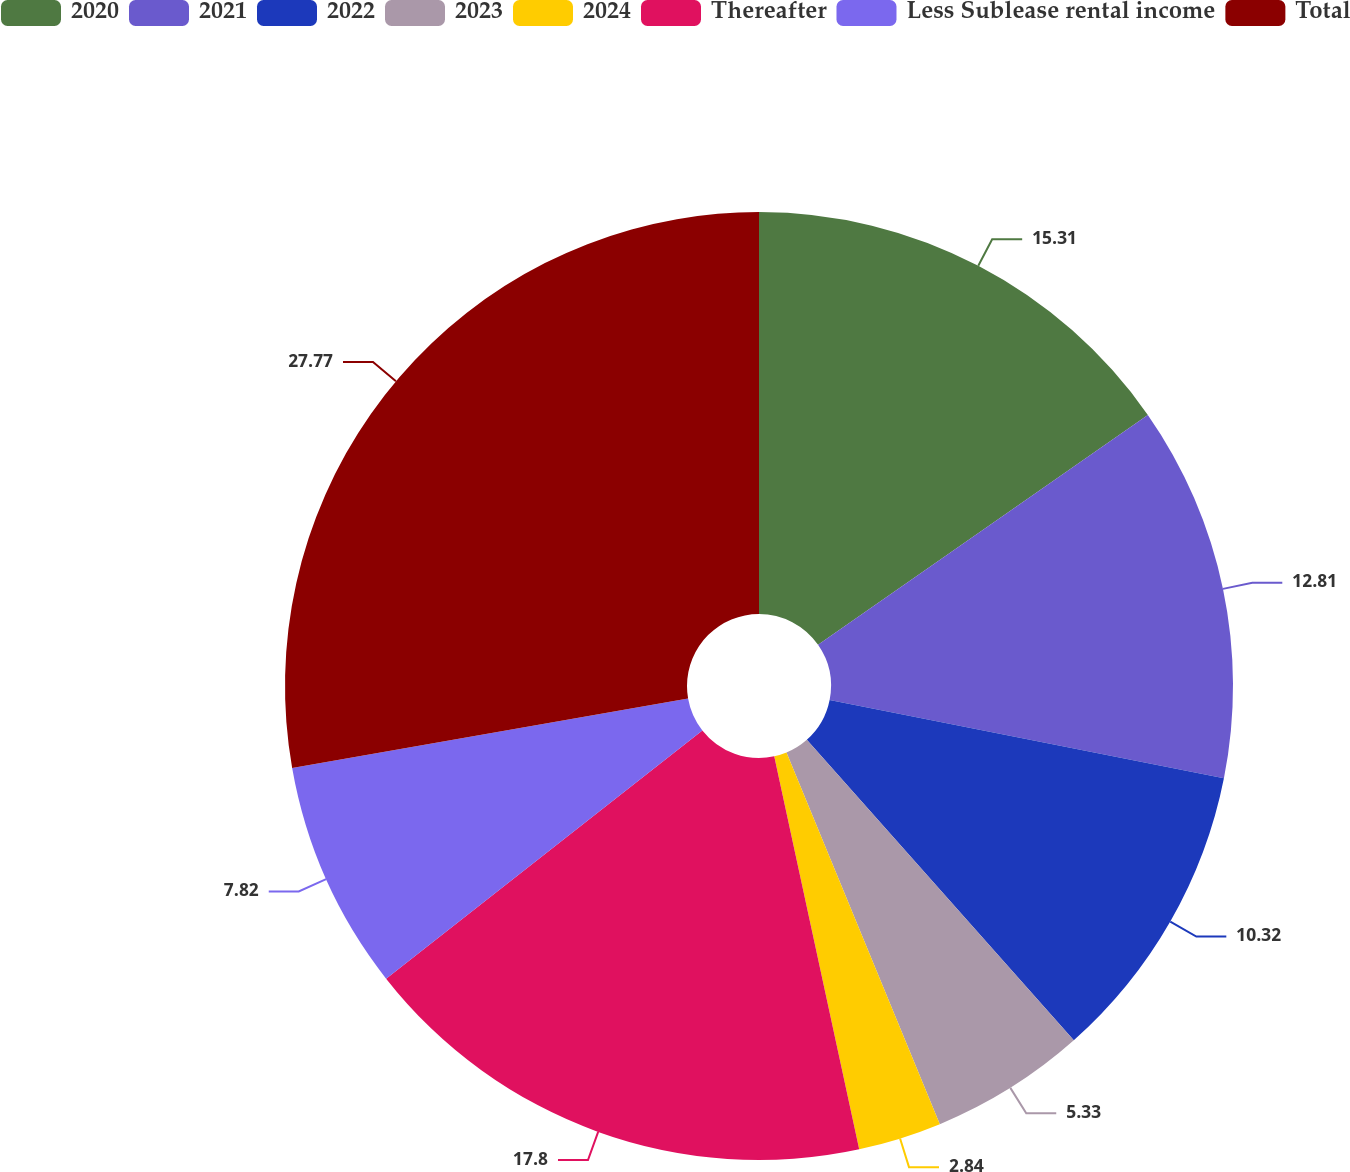Convert chart to OTSL. <chart><loc_0><loc_0><loc_500><loc_500><pie_chart><fcel>2020<fcel>2021<fcel>2022<fcel>2023<fcel>2024<fcel>Thereafter<fcel>Less Sublease rental income<fcel>Total<nl><fcel>15.31%<fcel>12.81%<fcel>10.32%<fcel>5.33%<fcel>2.84%<fcel>17.8%<fcel>7.82%<fcel>27.77%<nl></chart> 